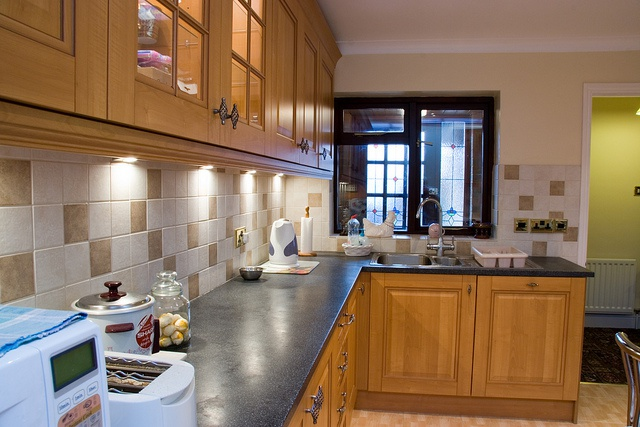Describe the objects in this image and their specific colors. I can see microwave in olive, lavender, lightblue, and darkgreen tones, toaster in olive, lightgray, darkgray, and black tones, sink in olive, gray, black, and maroon tones, chair in olive, maroon, black, and gray tones, and bottle in olive, darkgray, gray, and lightgray tones in this image. 